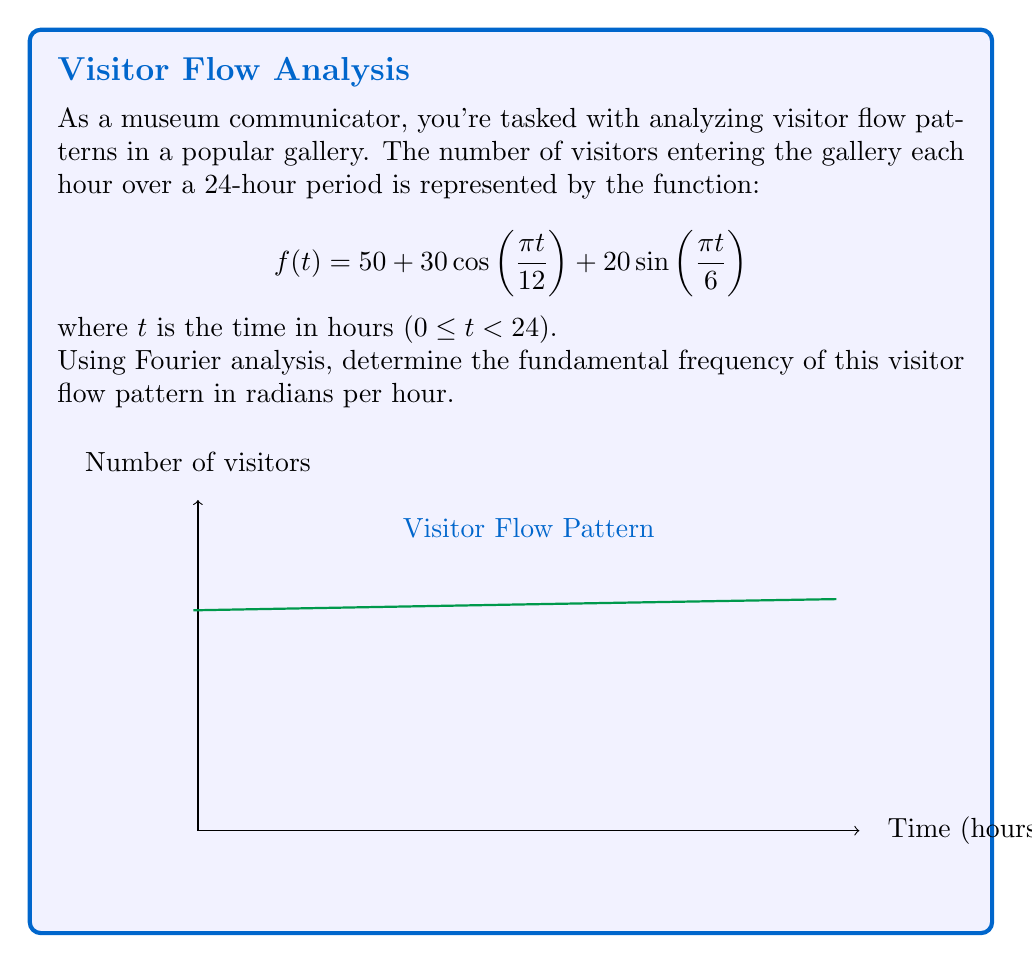Can you solve this math problem? To find the fundamental frequency using Fourier analysis, we follow these steps:

1) The given function is already in the form of a Fourier series:
   $$f(t) = A_0 + A_1\cos(\omega_1 t) + B_1\sin(\omega_2 t)$$

2) We identify the components:
   $A_0 = 50$ (constant term)
   $A_1 = 30$, $\omega_1 = \frac{\pi}{12}$
   $B_1 = 20$, $\omega_2 = \frac{\pi}{6}$

3) The fundamental frequency is the greatest common divisor (GCD) of all frequencies present in the Fourier series.

4) We have two frequencies: $\omega_1 = \frac{\pi}{12}$ and $\omega_2 = \frac{\pi}{6}$

5) To find the GCD:
   $\frac{\pi}{12} = \frac{\pi}{2 * 6}$
   $\frac{\pi}{6} = \frac{\pi}{1 * 6}$

6) The common factor is $\frac{\pi}{6}$, which is the larger of the two frequencies.

Therefore, the fundamental frequency is $\frac{\pi}{6}$ radians per hour.
Answer: $\frac{\pi}{6}$ radians/hour 